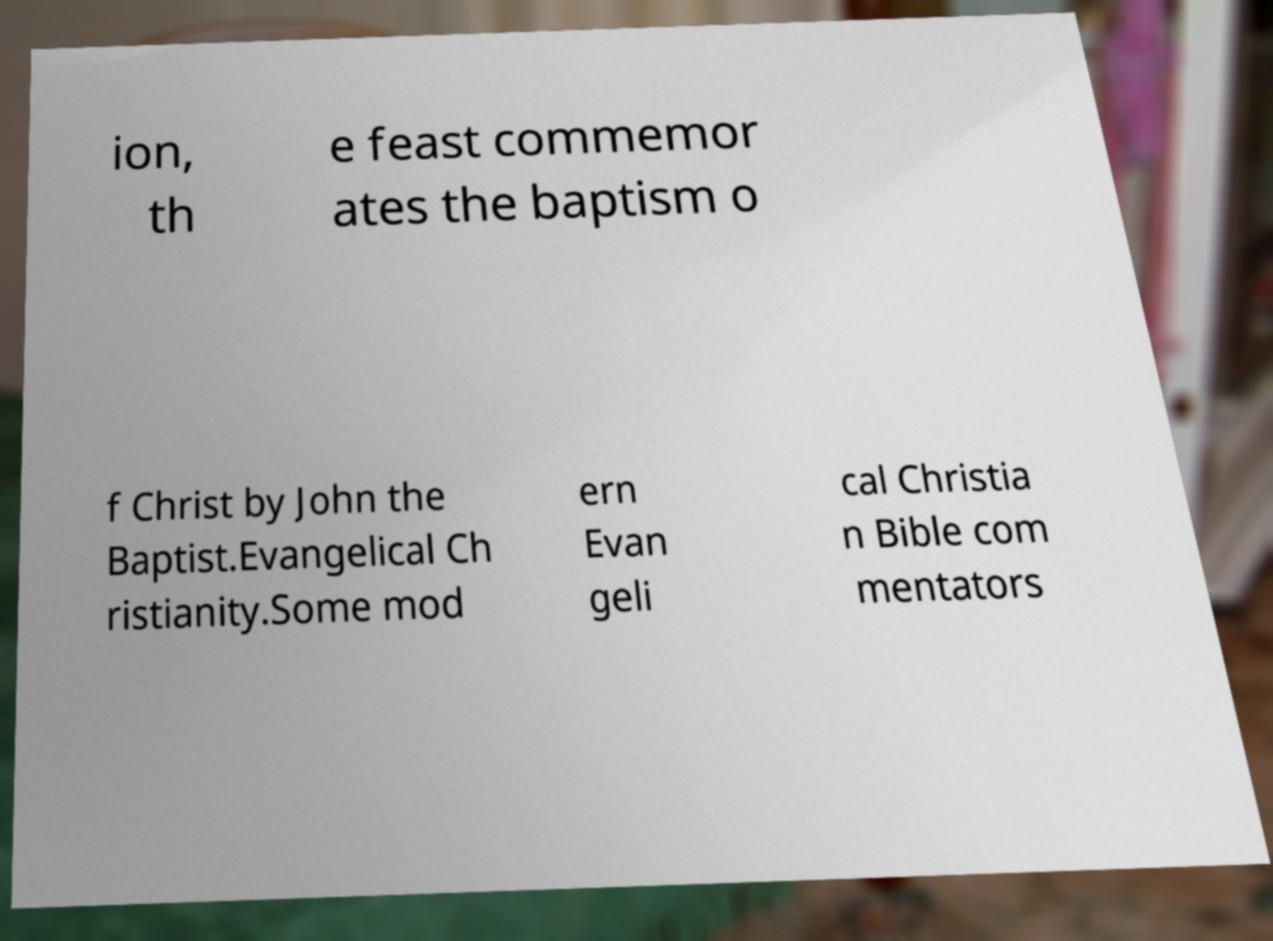Could you assist in decoding the text presented in this image and type it out clearly? ion, th e feast commemor ates the baptism o f Christ by John the Baptist.Evangelical Ch ristianity.Some mod ern Evan geli cal Christia n Bible com mentators 